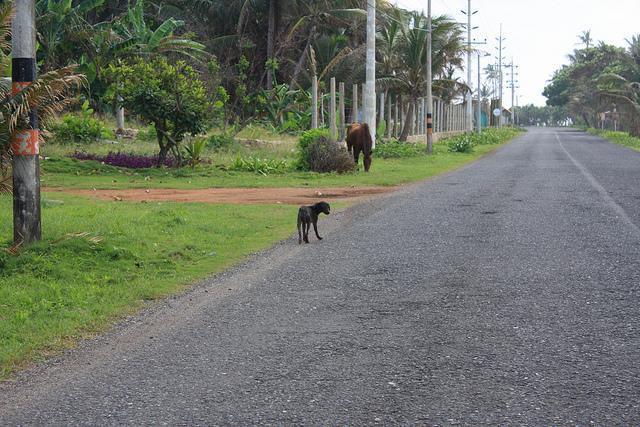How many cups on the table are wine glasses?
Give a very brief answer. 0. 